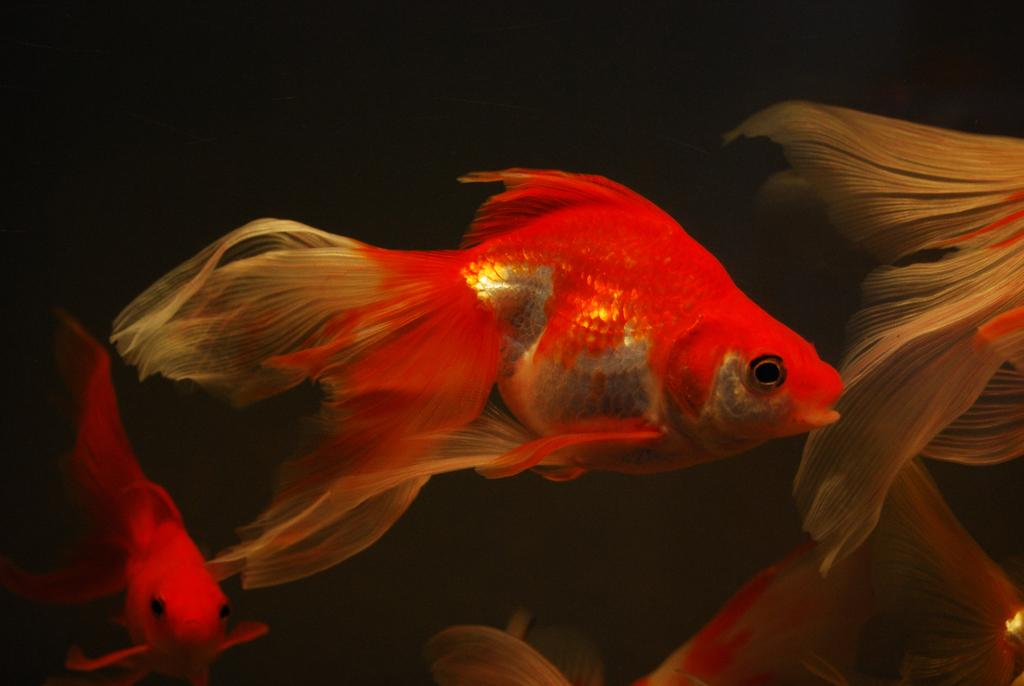What type of animals can be seen in the image? There are fishes in the image. What color are the fishes? The fishes are in orange color. What are the fishes doing in the image? The fishes are swimming in the water. What is the color of the background in the image? The background of the image is black. Where might this image have been taken? The image might have been taken in an aquarium. What type of lift can be seen in the image? There is no lift present in the image; it features fishes swimming in the water. What process is being carried out by the fishes in the image? The fishes are simply swimming in the water, and no specific process is being carried out. 